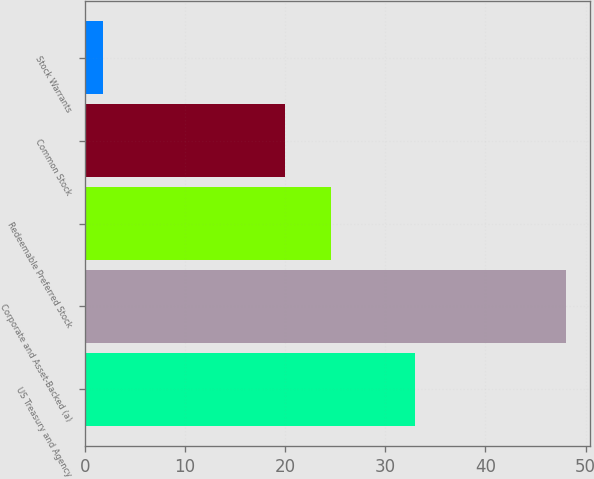<chart> <loc_0><loc_0><loc_500><loc_500><bar_chart><fcel>US Treasury and Agency<fcel>Corporate and Asset-Backed (a)<fcel>Redeemable Preferred Stock<fcel>Common Stock<fcel>Stock Warrants<nl><fcel>33<fcel>48<fcel>24.62<fcel>20<fcel>1.81<nl></chart> 